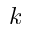Convert formula to latex. <formula><loc_0><loc_0><loc_500><loc_500>k</formula> 